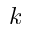Convert formula to latex. <formula><loc_0><loc_0><loc_500><loc_500>k</formula> 